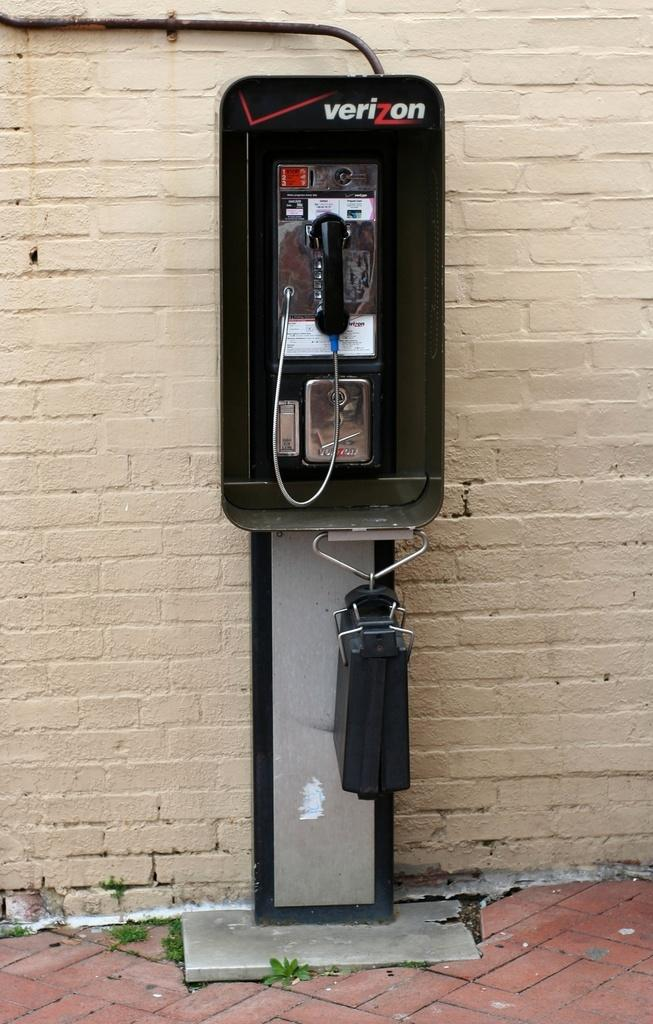What type of telephone booth is in the image? There is a Verizon telephone booth in the image. Where is the telephone booth located in the image? The telephone booth is in the center of the image. How many sisters are playing with a tin in the wilderness in the image? There are no sisters or tin present in the image, and the image does not depict a wilderness setting. 